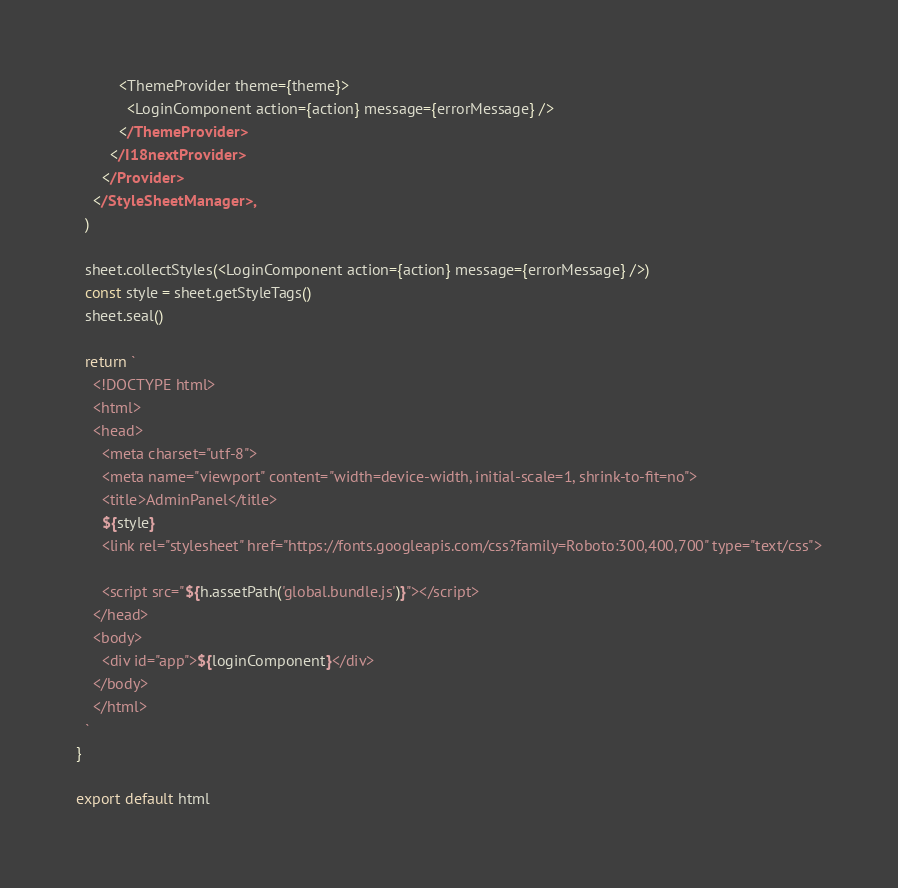<code> <loc_0><loc_0><loc_500><loc_500><_TypeScript_>          <ThemeProvider theme={theme}>
            <LoginComponent action={action} message={errorMessage} />
          </ThemeProvider>
        </I18nextProvider>
      </Provider>
    </StyleSheetManager>,
  )

  sheet.collectStyles(<LoginComponent action={action} message={errorMessage} />)
  const style = sheet.getStyleTags()
  sheet.seal()

  return `
    <!DOCTYPE html>
    <html>
    <head>
      <meta charset="utf-8">
      <meta name="viewport" content="width=device-width, initial-scale=1, shrink-to-fit=no">
      <title>AdminPanel</title>
      ${style}
      <link rel="stylesheet" href="https://fonts.googleapis.com/css?family=Roboto:300,400,700" type="text/css">

      <script src="${h.assetPath('global.bundle.js')}"></script>
    </head>
    <body>
      <div id="app">${loginComponent}</div>
    </body>
    </html>
  `
}

export default html
</code> 